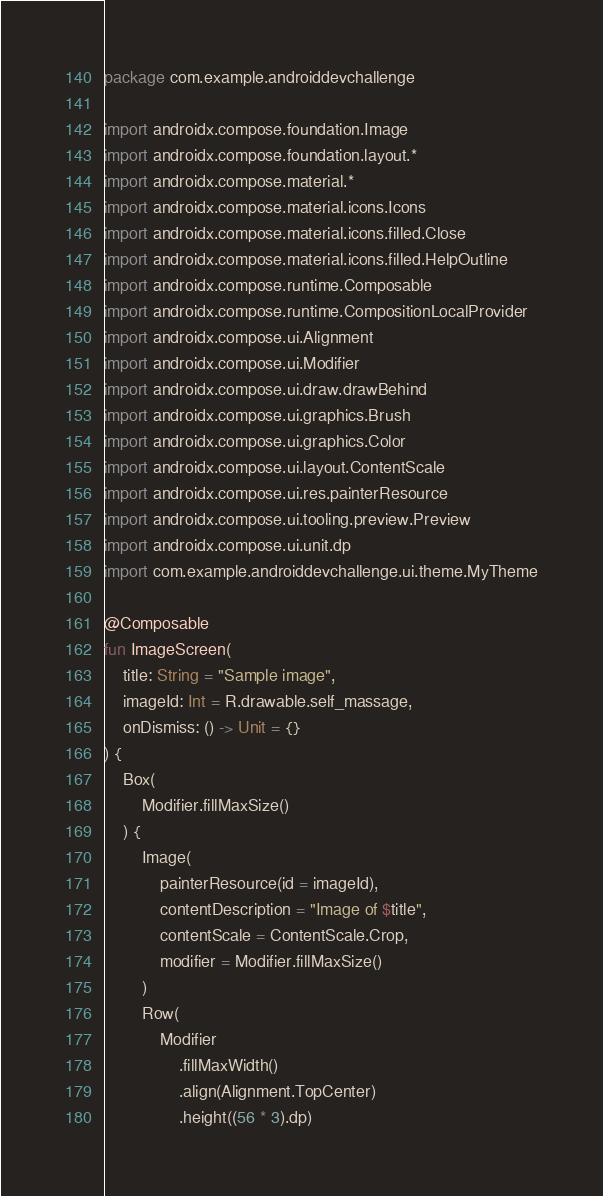<code> <loc_0><loc_0><loc_500><loc_500><_Kotlin_>package com.example.androiddevchallenge

import androidx.compose.foundation.Image
import androidx.compose.foundation.layout.*
import androidx.compose.material.*
import androidx.compose.material.icons.Icons
import androidx.compose.material.icons.filled.Close
import androidx.compose.material.icons.filled.HelpOutline
import androidx.compose.runtime.Composable
import androidx.compose.runtime.CompositionLocalProvider
import androidx.compose.ui.Alignment
import androidx.compose.ui.Modifier
import androidx.compose.ui.draw.drawBehind
import androidx.compose.ui.graphics.Brush
import androidx.compose.ui.graphics.Color
import androidx.compose.ui.layout.ContentScale
import androidx.compose.ui.res.painterResource
import androidx.compose.ui.tooling.preview.Preview
import androidx.compose.ui.unit.dp
import com.example.androiddevchallenge.ui.theme.MyTheme

@Composable
fun ImageScreen(
    title: String = "Sample image",
    imageId: Int = R.drawable.self_massage,
    onDismiss: () -> Unit = {}
) {
    Box(
        Modifier.fillMaxSize()
    ) {
        Image(
            painterResource(id = imageId),
            contentDescription = "Image of $title",
            contentScale = ContentScale.Crop,
            modifier = Modifier.fillMaxSize()
        )
        Row(
            Modifier
                .fillMaxWidth()
                .align(Alignment.TopCenter)
                .height((56 * 3).dp)</code> 